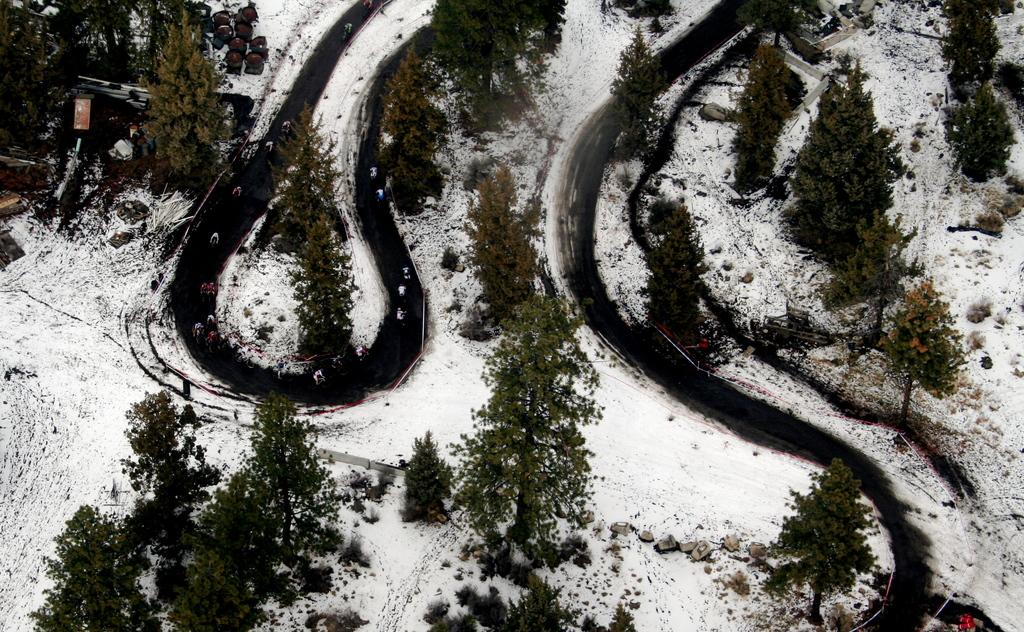What type of surface can be seen in the image? There are roads in the image. What is covering the ground in the image? There is snow on the ground in the image. What type of natural feature can be seen in the image? There are trees visible in the image. What type of shop can be seen in the image? There is no shop present in the image; it features roads, snow, and trees. How many dogs are visible in the image? There are no dogs present in the image. 